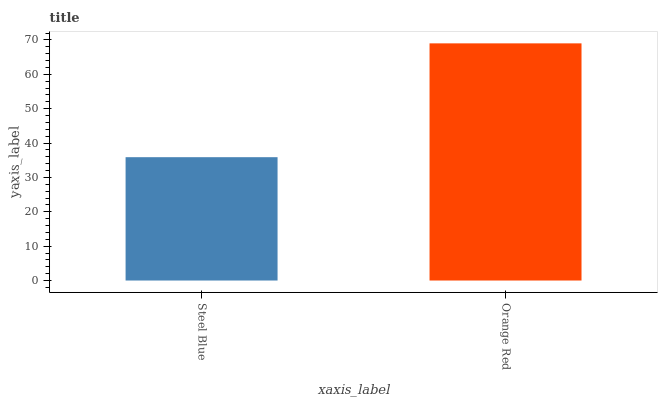Is Steel Blue the minimum?
Answer yes or no. Yes. Is Orange Red the maximum?
Answer yes or no. Yes. Is Orange Red the minimum?
Answer yes or no. No. Is Orange Red greater than Steel Blue?
Answer yes or no. Yes. Is Steel Blue less than Orange Red?
Answer yes or no. Yes. Is Steel Blue greater than Orange Red?
Answer yes or no. No. Is Orange Red less than Steel Blue?
Answer yes or no. No. Is Orange Red the high median?
Answer yes or no. Yes. Is Steel Blue the low median?
Answer yes or no. Yes. Is Steel Blue the high median?
Answer yes or no. No. Is Orange Red the low median?
Answer yes or no. No. 